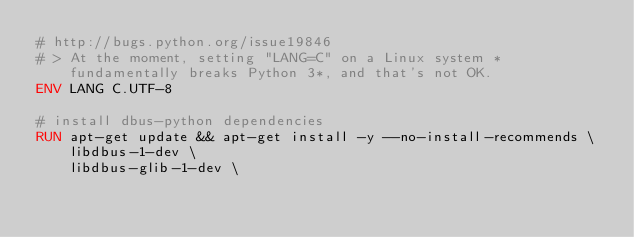Convert code to text. <code><loc_0><loc_0><loc_500><loc_500><_Dockerfile_># http://bugs.python.org/issue19846
# > At the moment, setting "LANG=C" on a Linux system *fundamentally breaks Python 3*, and that's not OK.
ENV LANG C.UTF-8

# install dbus-python dependencies 
RUN apt-get update && apt-get install -y --no-install-recommends \
		libdbus-1-dev \
		libdbus-glib-1-dev \</code> 